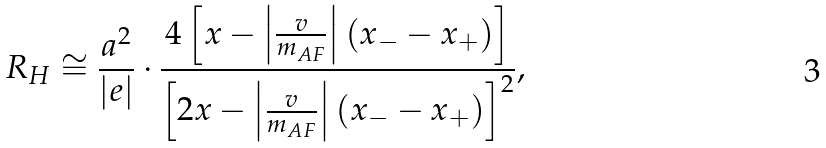Convert formula to latex. <formula><loc_0><loc_0><loc_500><loc_500>R _ { H } \cong \frac { a ^ { 2 } } { | e | } \cdot \frac { 4 \left [ x - \left | \frac { v } { m _ { A F } } \right | ( x _ { - } - x _ { + } ) \right ] } { \left [ 2 x - \left | \frac { v } { m _ { A F } } \right | ( x _ { - } - x _ { + } ) \right ] ^ { 2 } } ,</formula> 